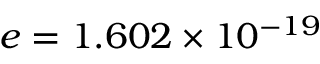Convert formula to latex. <formula><loc_0><loc_0><loc_500><loc_500>e = 1 . 6 0 2 \times 1 0 ^ { - 1 9 }</formula> 